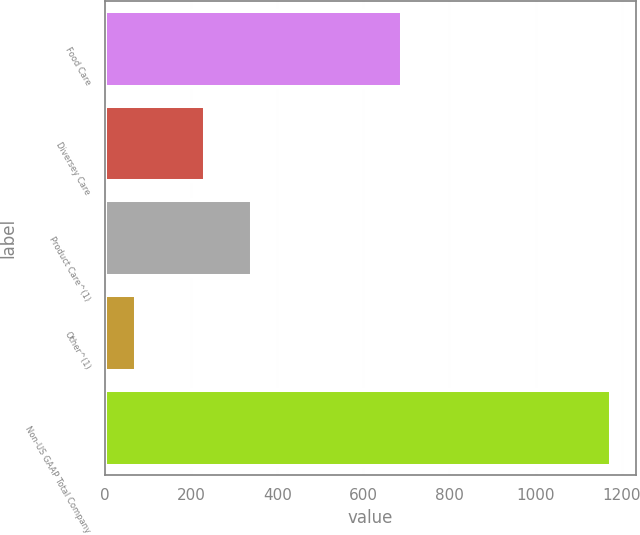Convert chart. <chart><loc_0><loc_0><loc_500><loc_500><bar_chart><fcel>Food Care<fcel>Diversey Care<fcel>Product Care^(1)<fcel>Other^(1)<fcel>Non-US GAAP Total Company<nl><fcel>689.8<fcel>231.9<fcel>342.14<fcel>71.7<fcel>1174.1<nl></chart> 